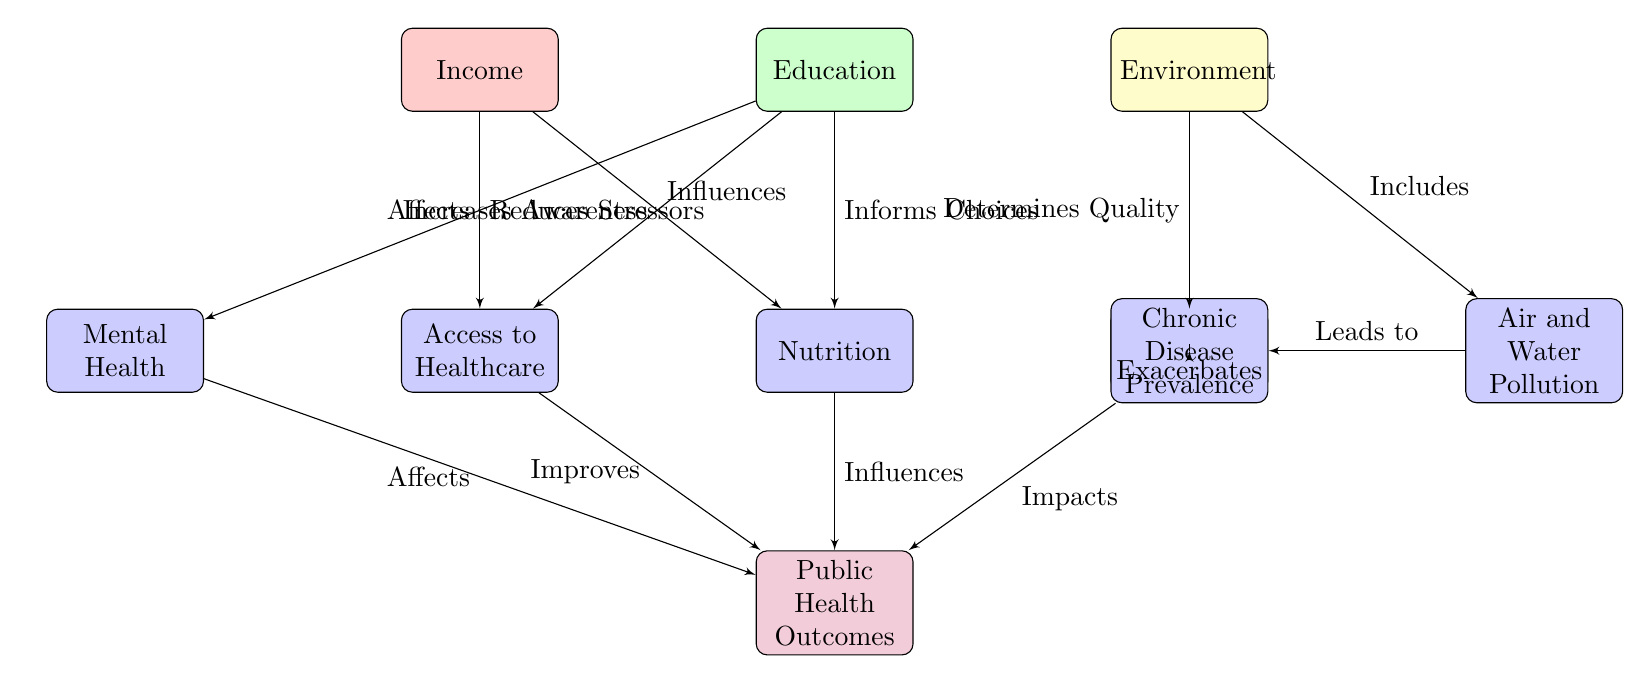What are the three main determinants of health in the diagram? The diagram specifically highlights Income, Education, and Environment as the three main determinants of health. These are the first three blocks depicted at the top of the diagram.
Answer: Income, Education, Environment What node is directly below Education? In the diagram, Nutrition is positioned directly below Education, indicating a direct relationship as the consequence or outcome influenced by Education.
Answer: Nutrition How many intermediate factors are there? The diagram shows five intermediate factors: Access to Healthcare, Nutrition, Housing, Air and Water Pollution, and Mental Health. By counting each block below the main determinants, we arrive at the total count.
Answer: 5 What is the outcome of the factors represented in the diagram? Public Health Outcomes is the final block located below the intermediate factors, signifying the overall result influenced by these determinants and factors.
Answer: Public Health Outcomes Which intermediate factor is influenced by both Income and Education? Nutrition is influenced by both Income (as seen from the arrow pointing from Income) and Education (with an arrow from Education). Therefore, it serves as a connection point for effects from both determinants.
Answer: Nutrition What relationship does Environment have with Housing? The relationship is described in the diagram as "Determines Quality," indicating that the state of the Environment directly impacts the quality of Housing. This relationship is represented by a directed arrow from Environment pointing towards Housing.
Answer: Determines Quality How does Access to Healthcare affect Public Health Outcomes? The diagram indicates an arrow labeled "Improves" from Access to Healthcare to Public Health Outcomes. This shows that better access positively influences overall public health results.
Answer: Improves Which factor leads to Chronic Disease Prevalence? The diagram connects Pollution to Chronic Disease Prevalence with a labeled arrow "Leads to," thus indicating that higher levels of Air and Water Pollution are associated with increased Chronic Disease rates.
Answer: Leads to What is the relationship between Mental Health and Public Health Outcomes? The diagram shows that Mental Health has a direct connection to Public Health Outcomes labeled as "Affects." This indicates that the state of Mental Health contributes to the overall public health results.
Answer: Affects 